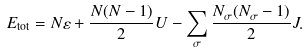Convert formula to latex. <formula><loc_0><loc_0><loc_500><loc_500>E _ { \text {tot} } = N \varepsilon + \frac { N ( N - 1 ) } { 2 } U - \sum _ { \sigma } \frac { N _ { \sigma } ( N _ { \sigma } - 1 ) } { 2 } J .</formula> 